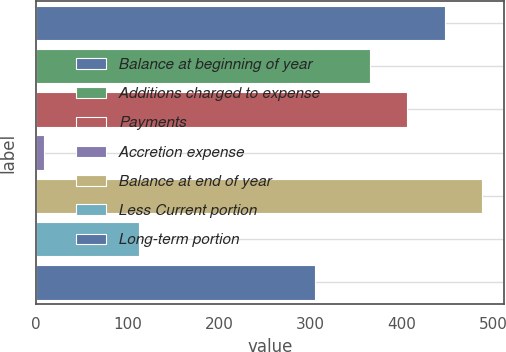<chart> <loc_0><loc_0><loc_500><loc_500><bar_chart><fcel>Balance at beginning of year<fcel>Additions charged to expense<fcel>Payments<fcel>Accretion expense<fcel>Balance at end of year<fcel>Less Current portion<fcel>Long-term portion<nl><fcel>446.68<fcel>364.9<fcel>405.79<fcel>8.3<fcel>487.57<fcel>112.7<fcel>304.5<nl></chart> 